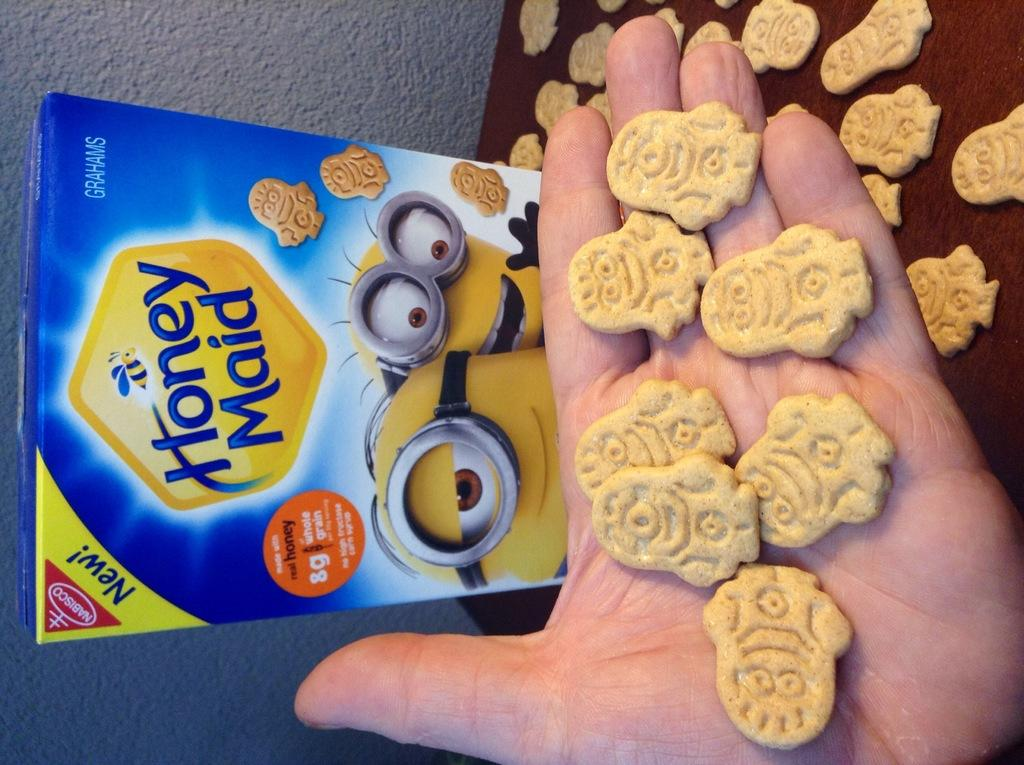Who or what is present in the image? There is a person in the image. What is the person holding in their hand? Biscuits are on the hand of the person. What else can be seen in the image besides the person? There is a box and biscuits on the table in the image. What can be seen in the background of the image? There is a wall in the background of the image. How does the person contribute to pollution in the image? There is no indication of pollution in the image, and the person's actions are not described in a way that would suggest they are contributing to pollution. 